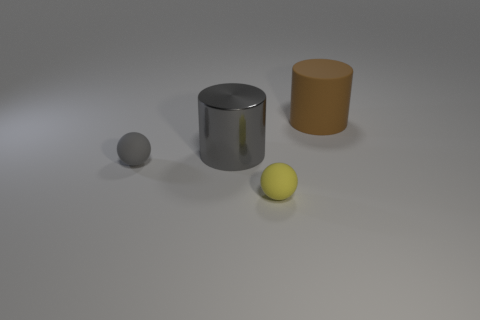Add 1 small gray cylinders. How many objects exist? 5 Add 2 large brown rubber cylinders. How many large brown rubber cylinders exist? 3 Subtract 1 gray cylinders. How many objects are left? 3 Subtract all large green matte blocks. Subtract all cylinders. How many objects are left? 2 Add 3 spheres. How many spheres are left? 5 